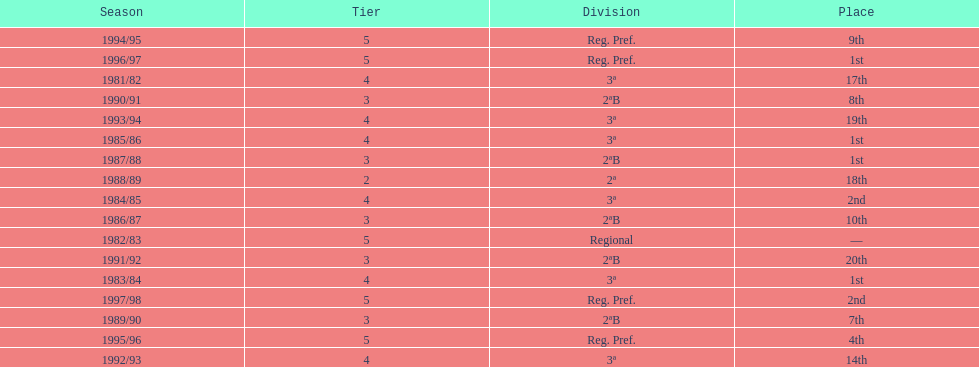How many seasons are shown in this chart? 17. 